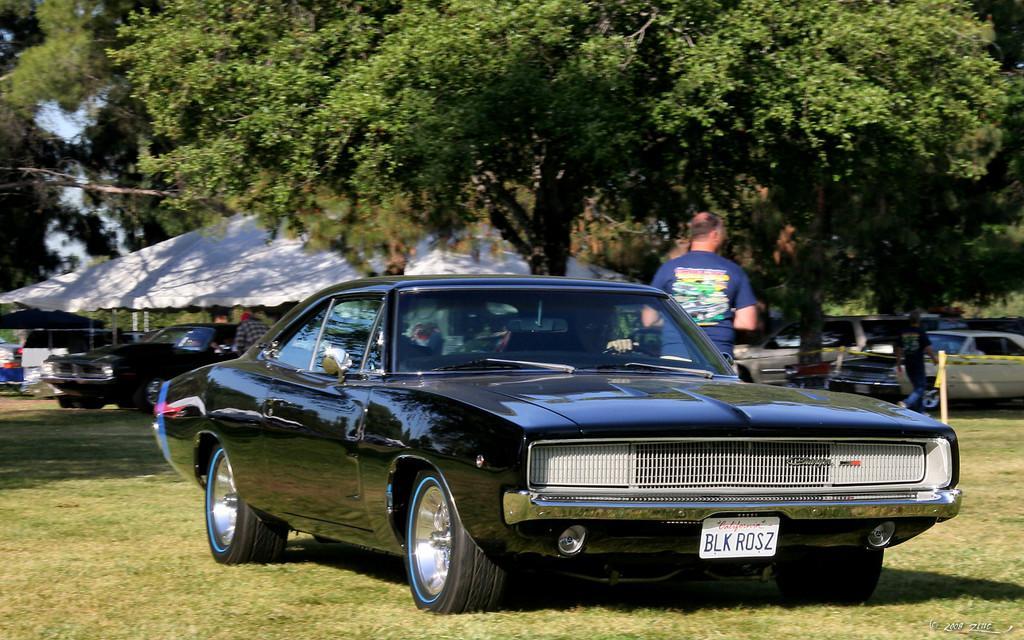How would you summarize this image in a sentence or two? In this picture there are vehicles and there are group people. At the back there is a tent and there are trees. At the top there is sky. At the bottom there is grass 